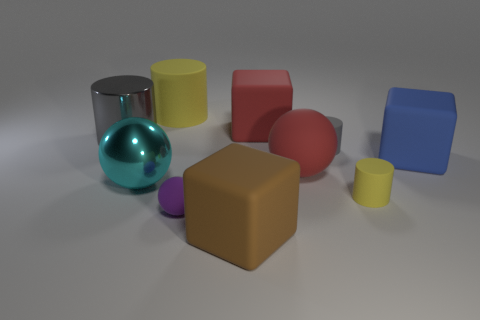Subtract all big metallic cylinders. How many cylinders are left? 3 Add 8 tiny yellow cylinders. How many tiny yellow cylinders are left? 9 Add 9 big blue matte cubes. How many big blue matte cubes exist? 10 Subtract 0 gray blocks. How many objects are left? 10 Subtract all cubes. How many objects are left? 7 Subtract 2 balls. How many balls are left? 1 Subtract all blue cylinders. Subtract all yellow balls. How many cylinders are left? 4 Subtract all gray blocks. How many purple cylinders are left? 0 Subtract all gray metallic objects. Subtract all large brown rubber cubes. How many objects are left? 8 